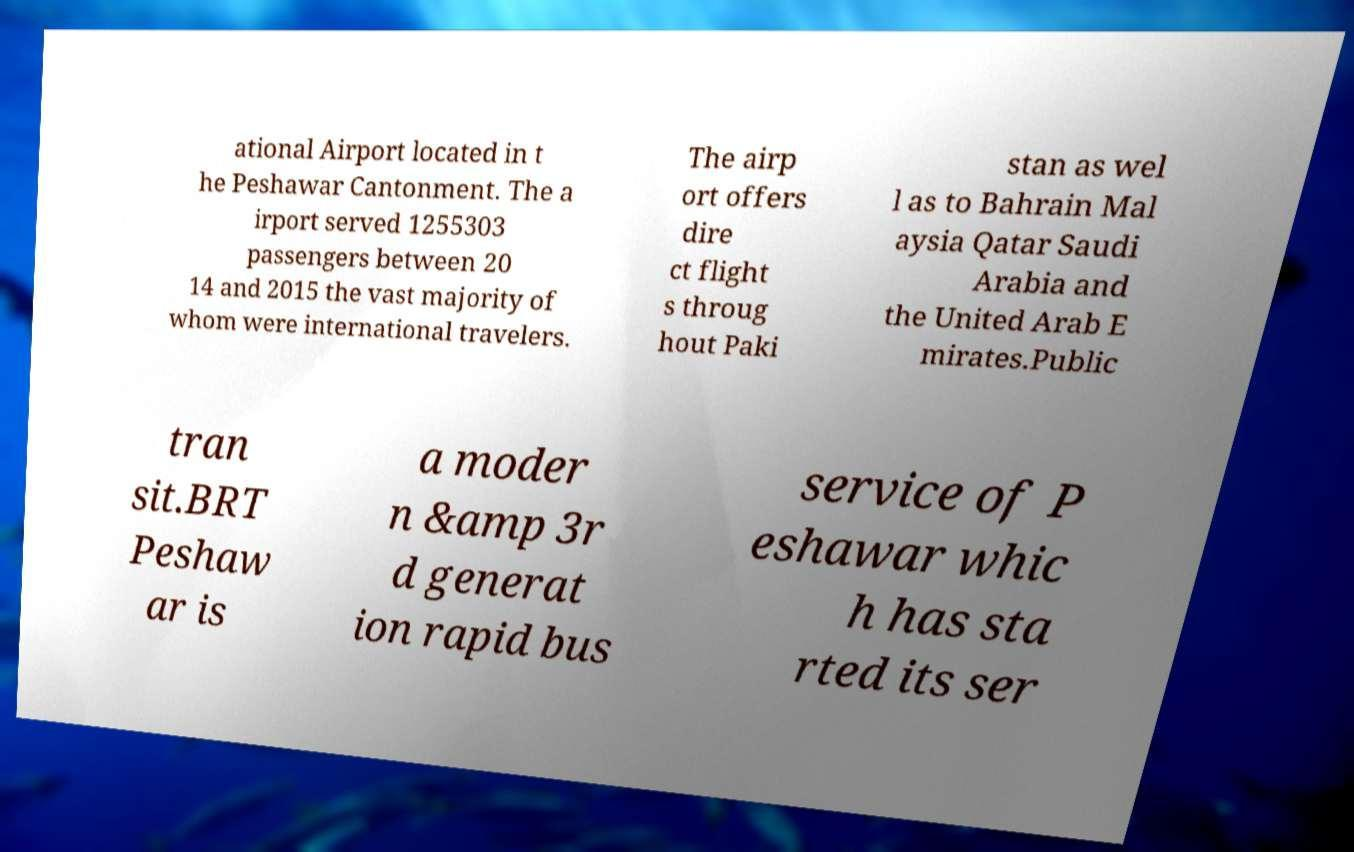Please read and relay the text visible in this image. What does it say? ational Airport located in t he Peshawar Cantonment. The a irport served 1255303 passengers between 20 14 and 2015 the vast majority of whom were international travelers. The airp ort offers dire ct flight s throug hout Paki stan as wel l as to Bahrain Mal aysia Qatar Saudi Arabia and the United Arab E mirates.Public tran sit.BRT Peshaw ar is a moder n &amp 3r d generat ion rapid bus service of P eshawar whic h has sta rted its ser 